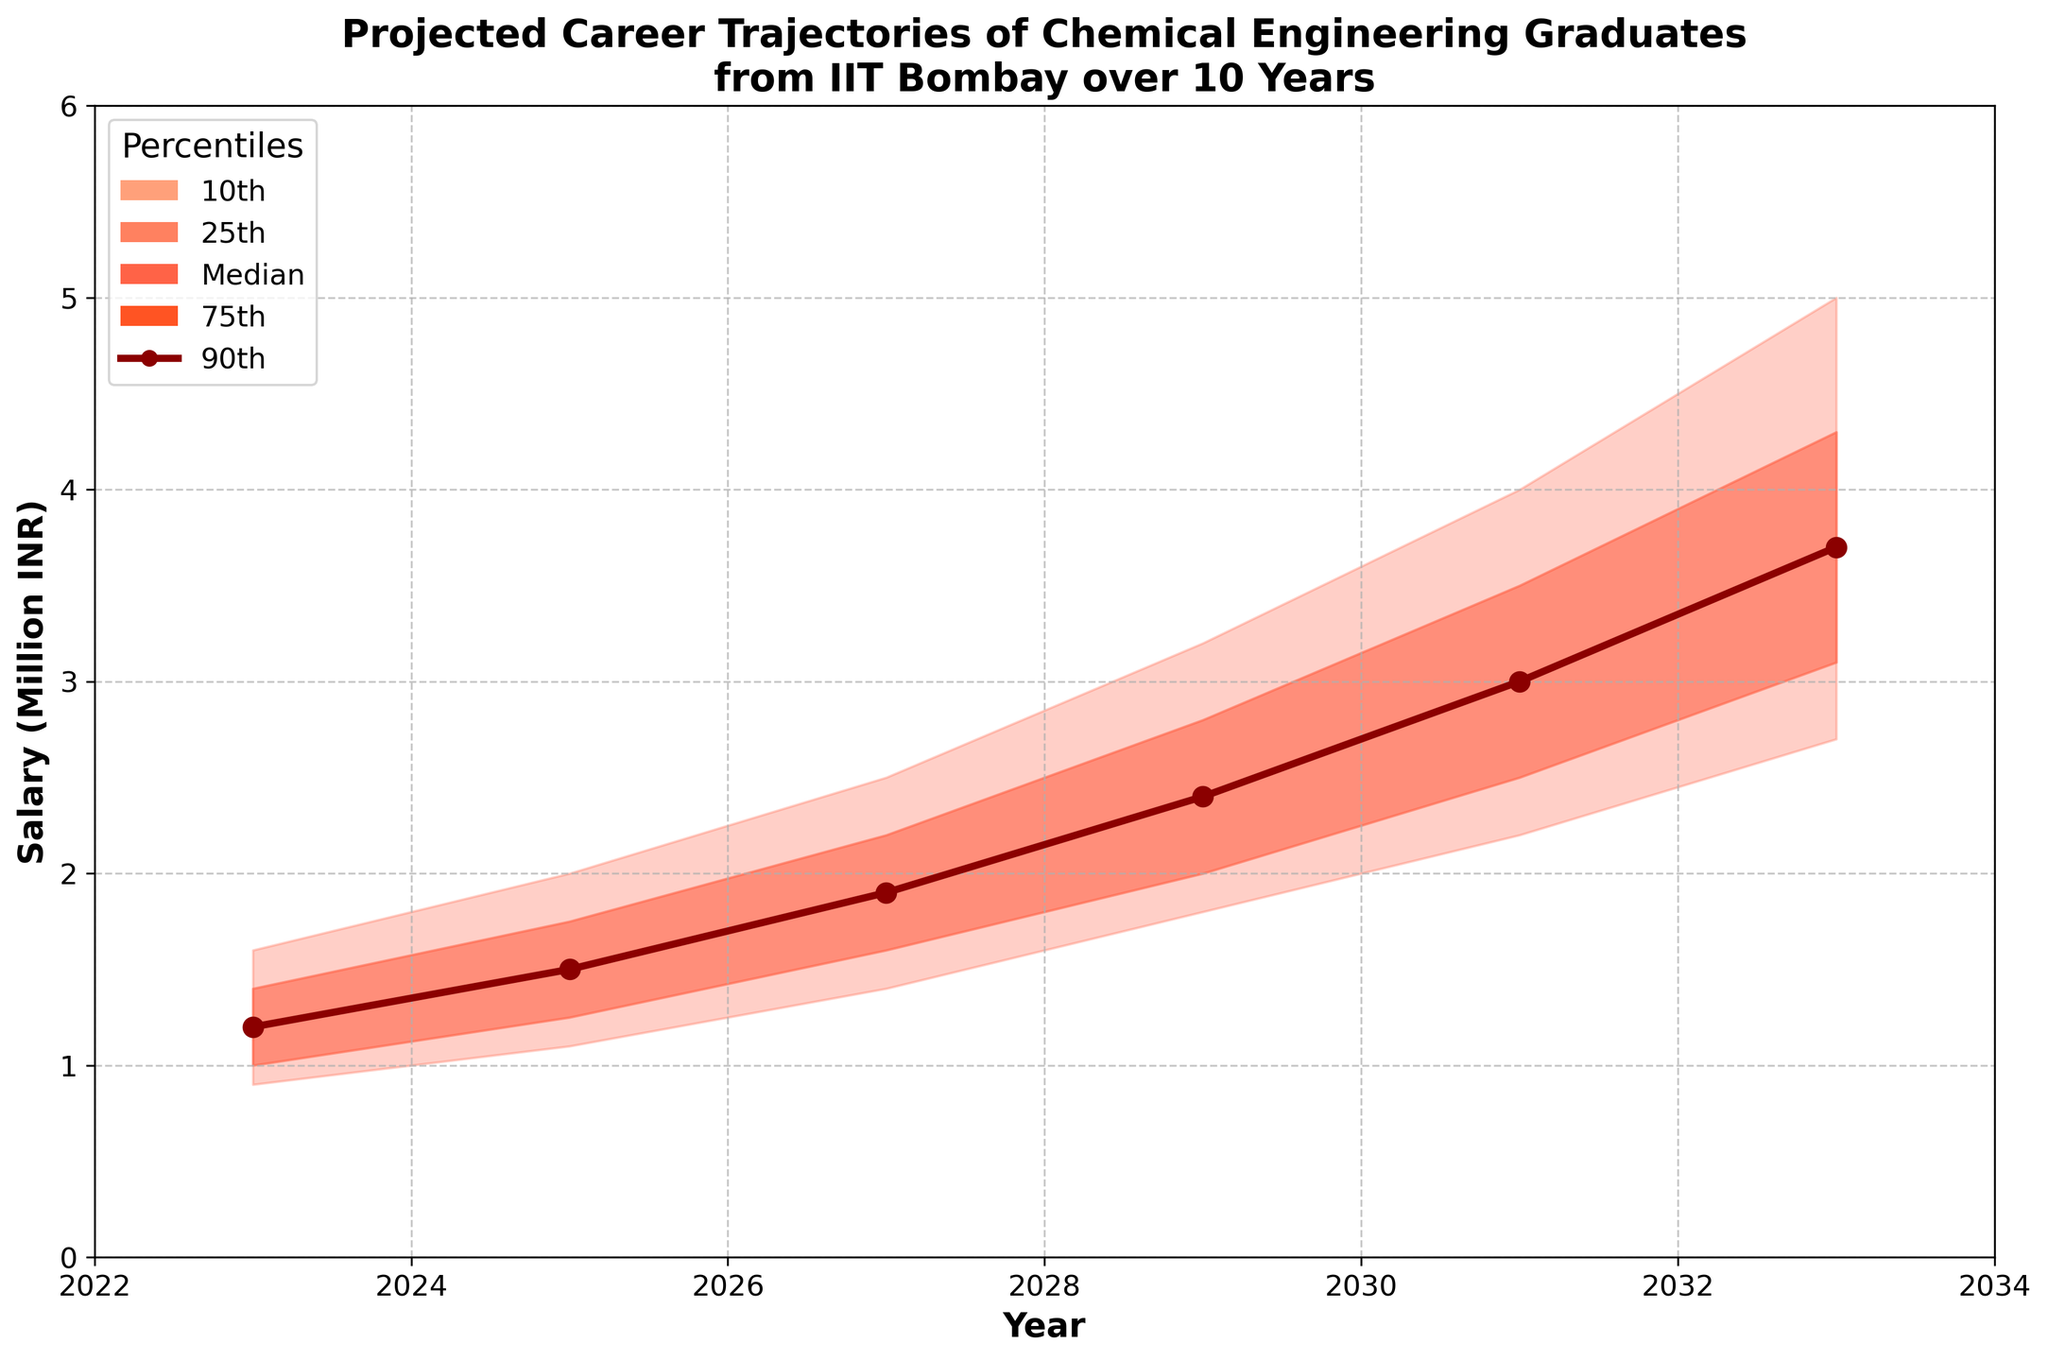What is the title of the figure? The title is usually found at the top of the figure and provides a summary of the plot's content. Here, it is stated clearly as "Projected Career Trajectories of Chemical Engineering Graduates from IIT Bombay over 10 Years."
Answer: Projected Career Trajectories of Chemical Engineering Graduates from IIT Bombay over 10 Years What is the median salary projected for 2029? The median salary for each year is represented by the line with markers. For 2029, the median salary value can be directly read off from the plot's line graph.
Answer: 2.4 million INR How does the 75th percentile salary in 2033 compare to the 25th percentile salary in the same year? To answer this, identify the 75th and 25th percentile salary values for 2033 and compare them. From the plot, the 75th percentile salary is above the 25th percentile salary. The exact values will show the 75th percentile is higher.
Answer: 4.3 million INR (75th) is higher than 3.1 million INR (25th) What is the range of salaries between the 10th and 90th percentiles in 2027? To find the range, we need to subtract the 10th percentile value from the 90th percentile value for the given year. For 2027, find the values and perform the subtraction.
Answer: 2.5 - 1.4 = 1.1 million INR What trend do you observe for the median salary over the years? Observing the median salary line over the years, identify if it increases, decreases, or remains the same. The line shows a consistently upward trend.
Answer: Increasing trend Between which years does the 25th percentile salary first surpass 2 million INR? Check the plot for the 25th percentile data and identify the first year it surpasses 2 million INR, then note the previous year as well.
Answer: Between 2029 and 2031 What is the difference in the median salary between 2025 and 2033? Find the median salary values for 2025 and 2033 and subtract the 2025 value from the 2033 value.
Answer: 3.7 - 1.5 = 2.2 million INR How many years of data are presented in the figure? Count the data points or range of years present in the figure from the x-axis labels.
Answer: 6 years By how much does the 90th percentile salary increase from 2023 to 2033? Find the 90th percentile salary values for 2023 and 2033 and subtract the 2023 value from the 2033 value.
Answer: 5 - 1.6 = 3.4 million INR What percentile range is shaded the darkest in the chart? Observe the shading patterns in the chart, with the darkest shade representing a narrower percentile range.
Answer: 25th to 75th percentiles 